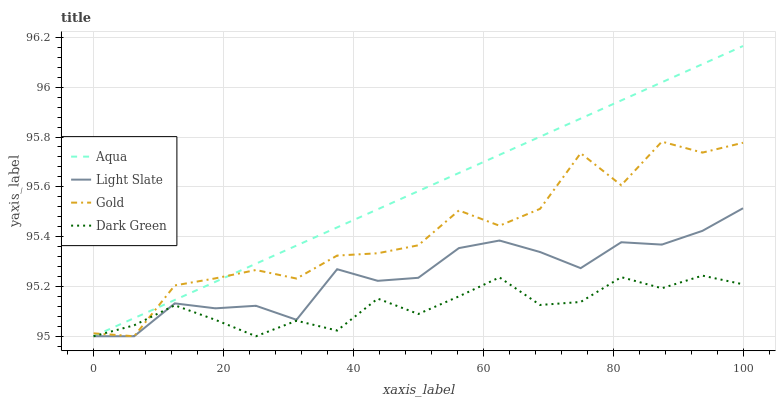Does Dark Green have the minimum area under the curve?
Answer yes or no. Yes. Does Aqua have the maximum area under the curve?
Answer yes or no. Yes. Does Gold have the minimum area under the curve?
Answer yes or no. No. Does Gold have the maximum area under the curve?
Answer yes or no. No. Is Aqua the smoothest?
Answer yes or no. Yes. Is Gold the roughest?
Answer yes or no. Yes. Is Gold the smoothest?
Answer yes or no. No. Is Aqua the roughest?
Answer yes or no. No. Does Light Slate have the lowest value?
Answer yes or no. Yes. Does Aqua have the highest value?
Answer yes or no. Yes. Does Gold have the highest value?
Answer yes or no. No. Does Light Slate intersect Dark Green?
Answer yes or no. Yes. Is Light Slate less than Dark Green?
Answer yes or no. No. Is Light Slate greater than Dark Green?
Answer yes or no. No. 